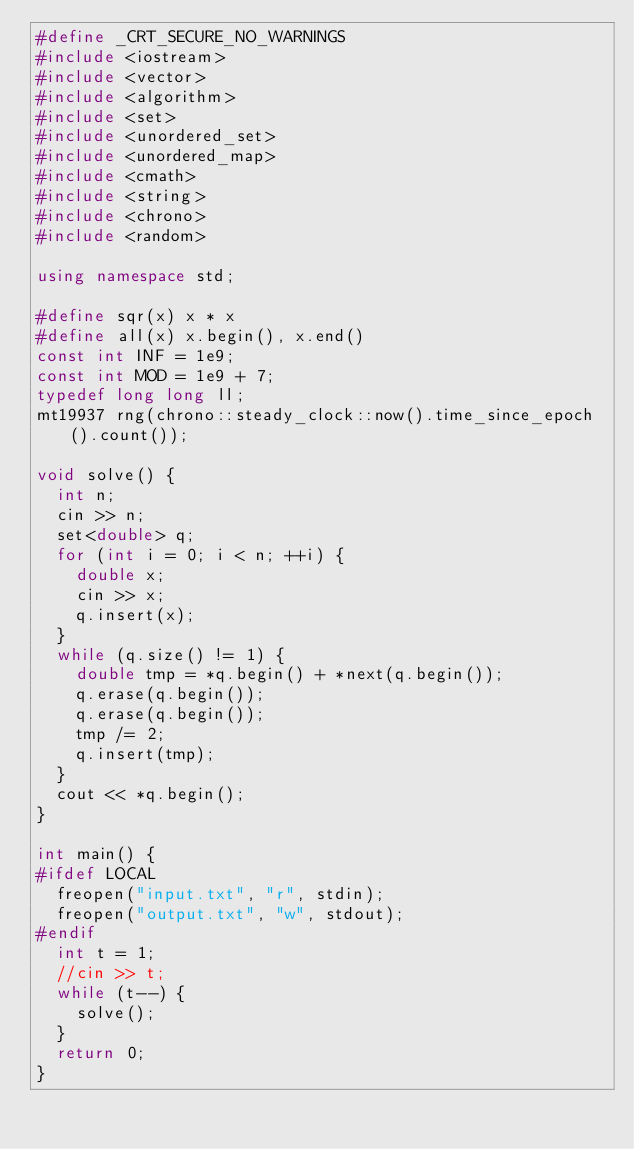<code> <loc_0><loc_0><loc_500><loc_500><_C++_>#define _CRT_SECURE_NO_WARNINGS
#include <iostream>
#include <vector>
#include <algorithm>
#include <set>
#include <unordered_set>
#include <unordered_map>
#include <cmath>
#include <string>
#include <chrono>
#include <random>

using namespace std;

#define sqr(x) x * x
#define all(x) x.begin(), x.end()
const int INF = 1e9;
const int MOD = 1e9 + 7;
typedef long long ll;
mt19937 rng(chrono::steady_clock::now().time_since_epoch().count());

void solve() {
	int n;
	cin >> n;
	set<double> q;
	for (int i = 0; i < n; ++i) {
		double x;
		cin >> x;
		q.insert(x);
	}
	while (q.size() != 1) {
		double tmp = *q.begin() + *next(q.begin());
		q.erase(q.begin());
		q.erase(q.begin());
		tmp /= 2;
		q.insert(tmp);
	}
	cout << *q.begin();
}

int main() {
#ifdef LOCAL
	freopen("input.txt", "r", stdin);
	freopen("output.txt", "w", stdout);
#endif
	int t = 1;
	//cin >> t;
	while (t--) {
		solve();
	}
	return 0;
}</code> 